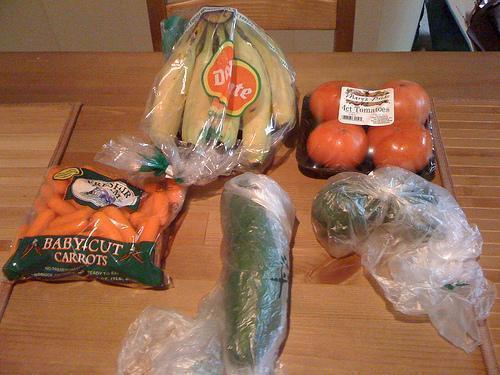How many tomatoes are there?
Give a very brief answer. 4. 